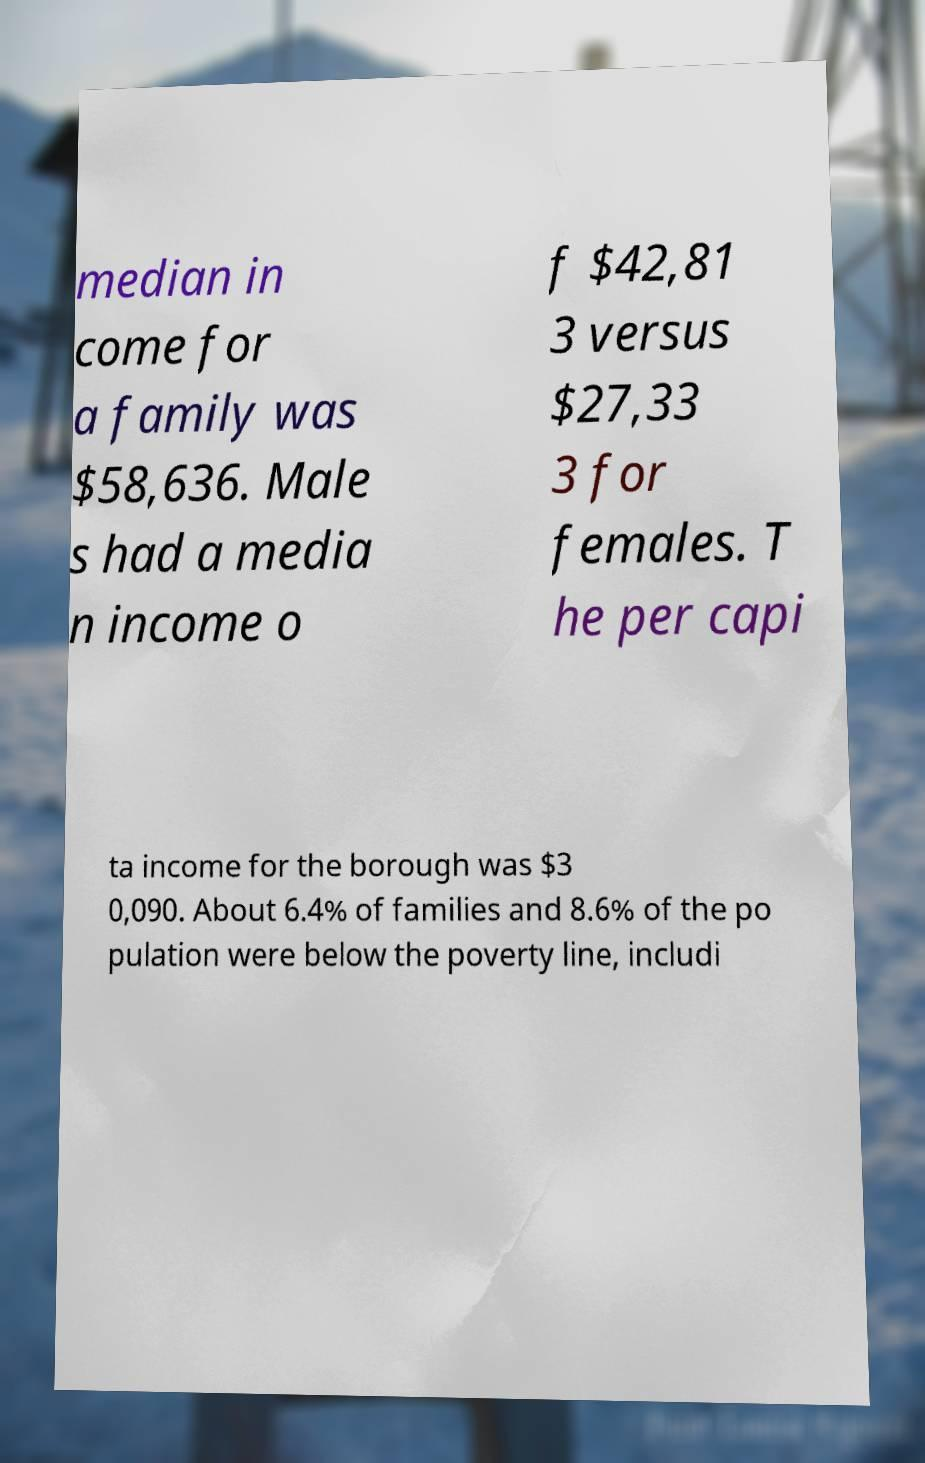I need the written content from this picture converted into text. Can you do that? median in come for a family was $58,636. Male s had a media n income o f $42,81 3 versus $27,33 3 for females. T he per capi ta income for the borough was $3 0,090. About 6.4% of families and 8.6% of the po pulation were below the poverty line, includi 